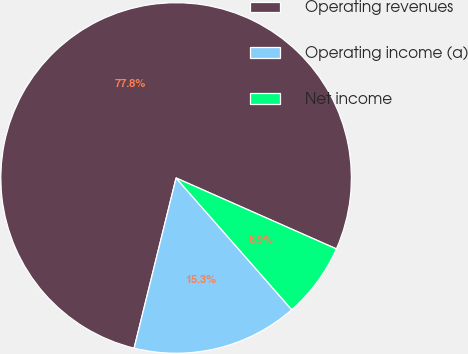<chart> <loc_0><loc_0><loc_500><loc_500><pie_chart><fcel>Operating revenues<fcel>Operating income (a)<fcel>Net income<nl><fcel>77.77%<fcel>15.32%<fcel>6.9%<nl></chart> 